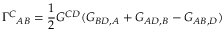<formula> <loc_0><loc_0><loc_500><loc_500>\Gamma ^ { C _ { A B } = \frac { 1 } { 2 } G ^ { C D } ( G _ { B D , A } + G _ { A D , B } - G _ { A B , D } )</formula> 